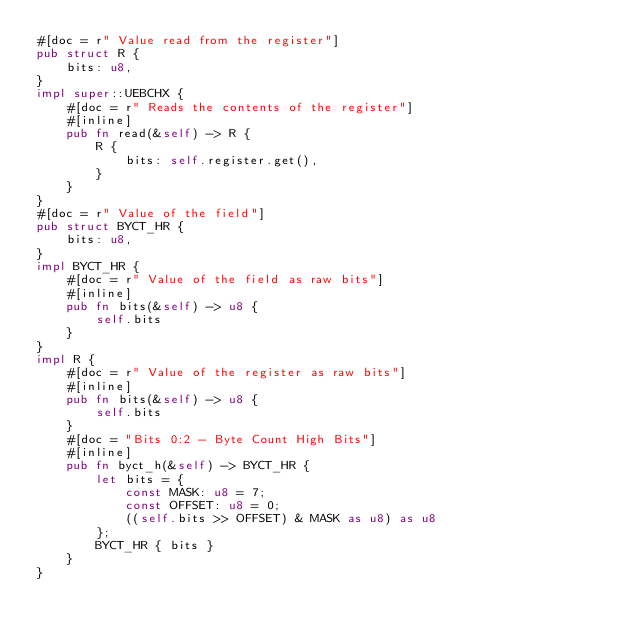<code> <loc_0><loc_0><loc_500><loc_500><_Rust_>#[doc = r" Value read from the register"]
pub struct R {
    bits: u8,
}
impl super::UEBCHX {
    #[doc = r" Reads the contents of the register"]
    #[inline]
    pub fn read(&self) -> R {
        R {
            bits: self.register.get(),
        }
    }
}
#[doc = r" Value of the field"]
pub struct BYCT_HR {
    bits: u8,
}
impl BYCT_HR {
    #[doc = r" Value of the field as raw bits"]
    #[inline]
    pub fn bits(&self) -> u8 {
        self.bits
    }
}
impl R {
    #[doc = r" Value of the register as raw bits"]
    #[inline]
    pub fn bits(&self) -> u8 {
        self.bits
    }
    #[doc = "Bits 0:2 - Byte Count High Bits"]
    #[inline]
    pub fn byct_h(&self) -> BYCT_HR {
        let bits = {
            const MASK: u8 = 7;
            const OFFSET: u8 = 0;
            ((self.bits >> OFFSET) & MASK as u8) as u8
        };
        BYCT_HR { bits }
    }
}
</code> 